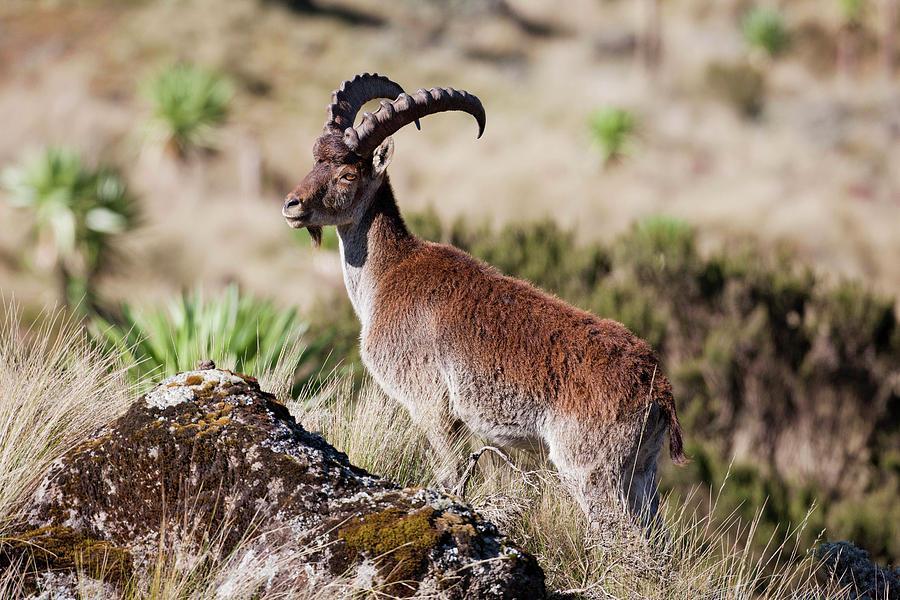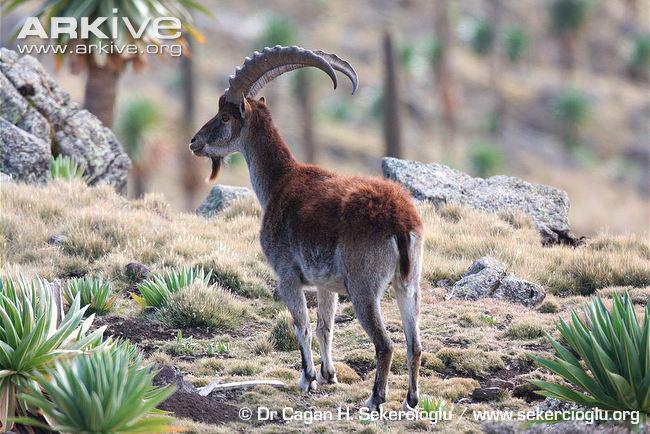The first image is the image on the left, the second image is the image on the right. For the images shown, is this caption "The left and right image contains the same number of goats standing in opposite directions." true? Answer yes or no. No. The first image is the image on the left, the second image is the image on the right. For the images displayed, is the sentence "Each image depicts one horned animal, and the horned animals in the left and right images face the same direction." factually correct? Answer yes or no. Yes. 